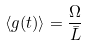<formula> <loc_0><loc_0><loc_500><loc_500>\langle g ( t ) \rangle = \frac { \Omega } { \bar { L } }</formula> 